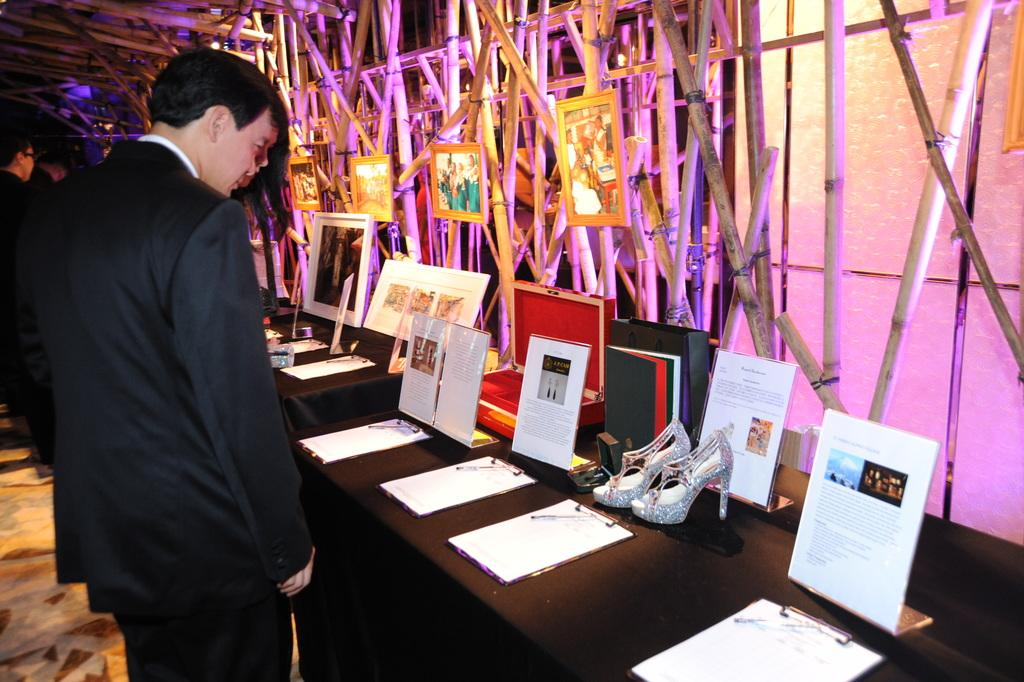What can be seen on the left side of the image? There are persons standing at the left side of the image. What is located on the table in the image? There are objects placed on a table in the image. What type of body is visible in the image? There is no specific body visible in the image; it features persons standing and objects on a table. Are there any police officers present in the image? There is no mention of police officers in the provided facts, so it cannot be determined if they are present in the image. 